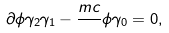Convert formula to latex. <formula><loc_0><loc_0><loc_500><loc_500>\partial \phi \gamma _ { 2 } \gamma _ { 1 } - \frac { m c } { } \phi \gamma _ { 0 } = 0 ,</formula> 